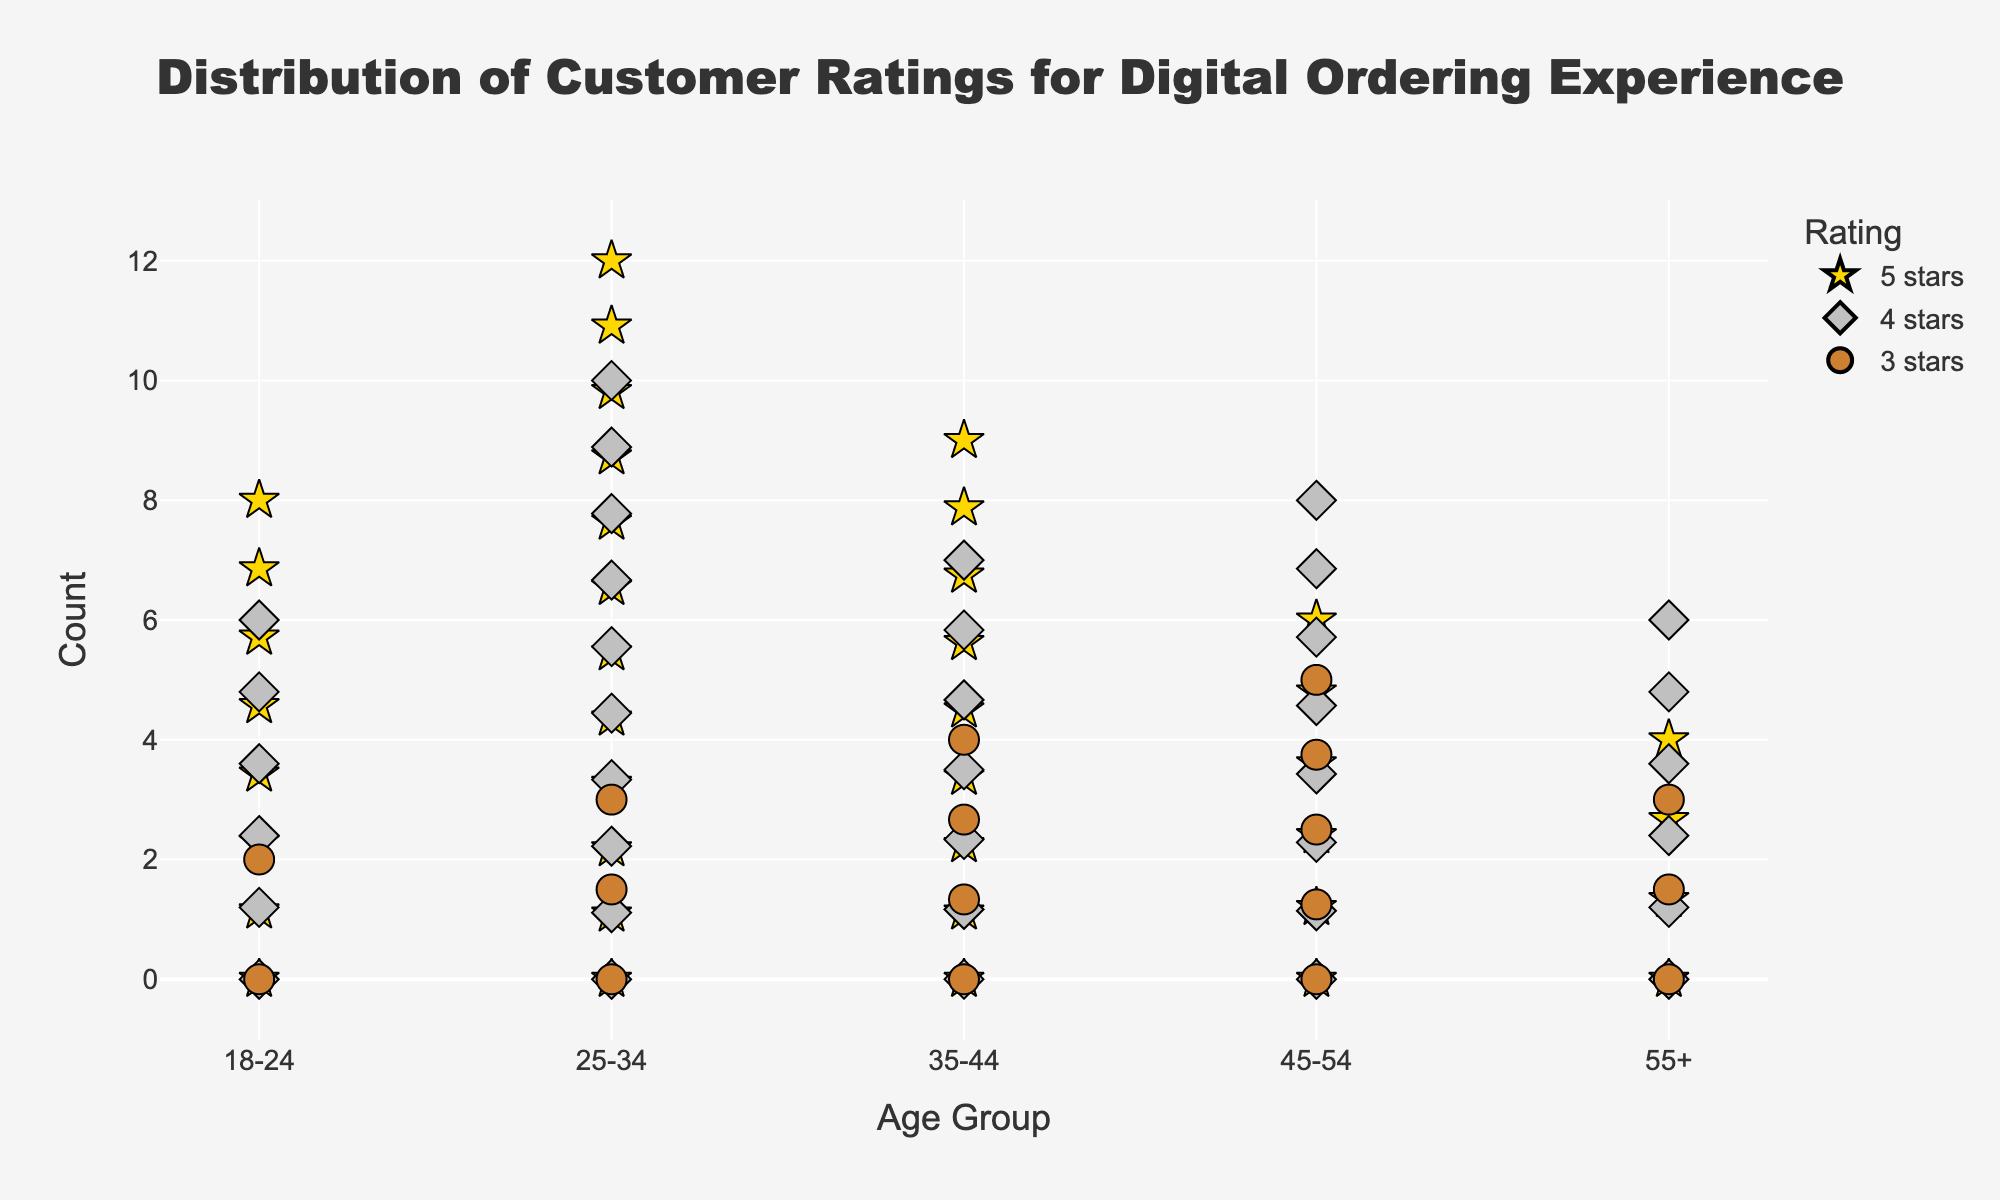What is the title of the figure? The title is prominently displayed at the top center of the plot, phrased in a large, bold font.
Answer: Distribution of Customer Ratings for Digital Ordering Experience Which age group received the highest number of 5-star ratings? Look for the age group with the longest series of symbols representing 5-star ratings (stars) along the y-axis. The 25-34 age group has the longest star series.
Answer: 25-34 What rating has the fewest markers for the age group 55+? For the age group 55+, note that the smallest series of markers corresponds to the 3-star ratings, indicated by circles.
Answer: 3 stars How many total customers rated the digital ordering experience for the age group 18-24? Sum the counts of each rating type (5 stars, 4 stars, and 3 stars) for the 18-24 age group. The counts are 8, 6, and 2.
Answer: 16 Which rating seems to be the most common across all age groups? Observe which rating type (symbol) appears the most frequently throughout the figure. The stars representing 5-star ratings appear more often than diamonds (4-star) and circles (3-star).
Answer: 5 stars Which age group has more 4-star ratings compared to 5-star ratings? Identify any age group where the series of diamonds (4-star) is longer than the series of stars (5-star). The 45-54 group has 8 (4 stars) and 6 (5 stars).
Answer: 45-54 How many 5-star ratings were received by customers aged 35-44? Count the number of star symbols for the 35-44 age group. There are 9 stars for this age group.
Answer: 9 What is the normalized count of 5-star ratings for the age group 25-34? The normalized count is calculated by dividing the number of 5-star ratings by the total ratings count for the age group 25-34. The normalized count would be 12/(12+10+3) = 12/25 = 0.48.
Answer: 0.48 Compare the number of 3-star ratings between the age groups 18-24 and 45-54. Which group has more? Look at the count of circle markers for both age groups. The count of 3-star ratings for 18-24 is 2 and for 45-54 is 5, thus 45-54 has more.
Answer: 45-54 What is the general trend in customer ratings as the age groups increase? Examine the distribution of ratings (symbols) across age groups and observe any pattern. Notice that older age groups tend to have fewer 5-stars and more lower ratings.
Answer: Older groups show a trend toward fewer 5-star and more lower ratings 